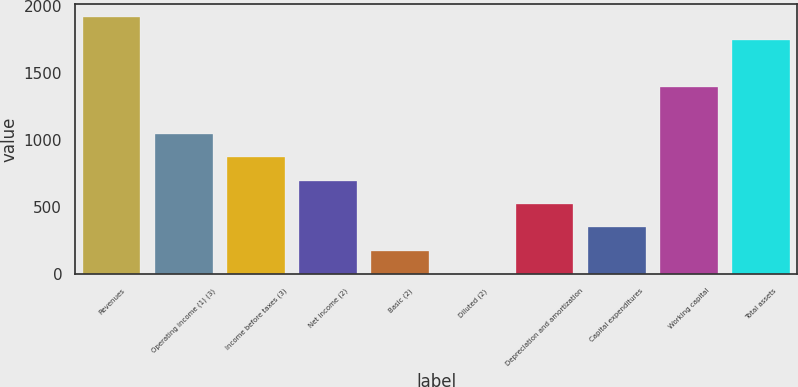Convert chart. <chart><loc_0><loc_0><loc_500><loc_500><bar_chart><fcel>Revenues<fcel>Operating income (1) (3)<fcel>Income before taxes (3)<fcel>Net income (2)<fcel>Basic (2)<fcel>Diluted (2)<fcel>Depreciation and amortization<fcel>Capital expenditures<fcel>Working capital<fcel>Total assets<nl><fcel>1922.09<fcel>1048.99<fcel>874.37<fcel>699.75<fcel>175.89<fcel>1.27<fcel>525.13<fcel>350.51<fcel>1398.23<fcel>1747.47<nl></chart> 